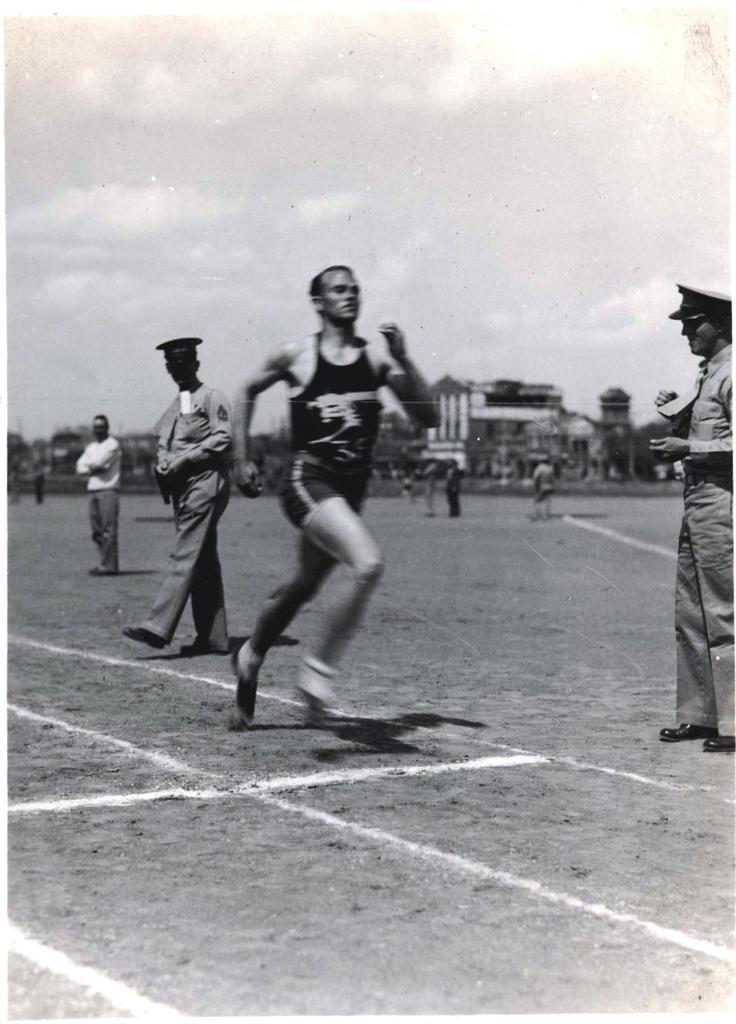Could you give a brief overview of what you see in this image? In this picture there is a man who is running on the ground, besides him I can see the officers who are wearing cap, shirt, trouser and shoes. In the back I can see many people who are standing on the ground. In the background I can see the trees, plants, grass and buildings. At the top I can see the sky and clouds. At the bottom I can see the white lines. 